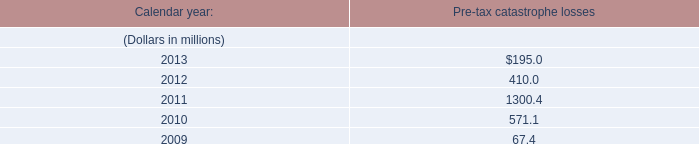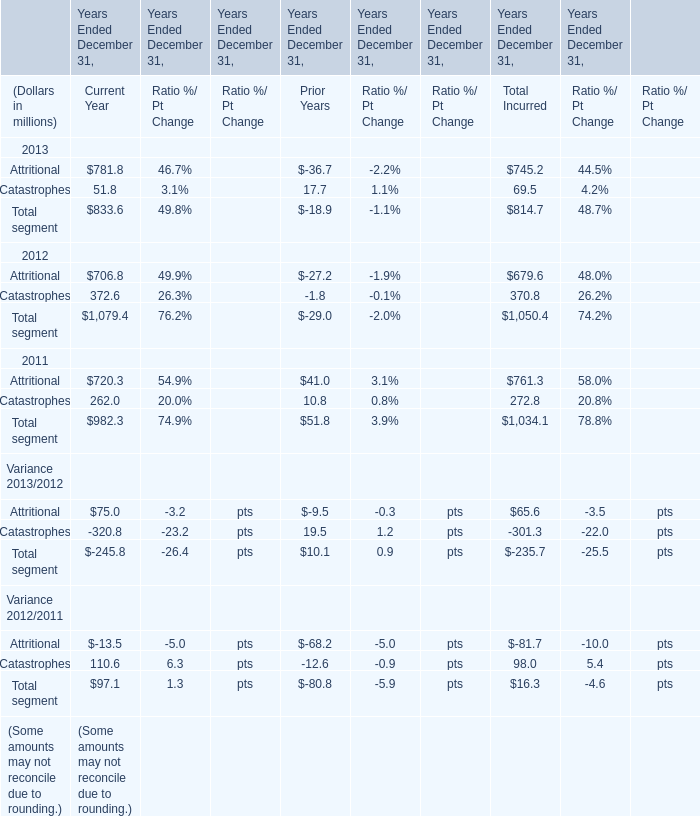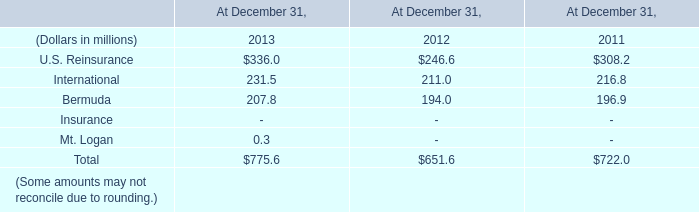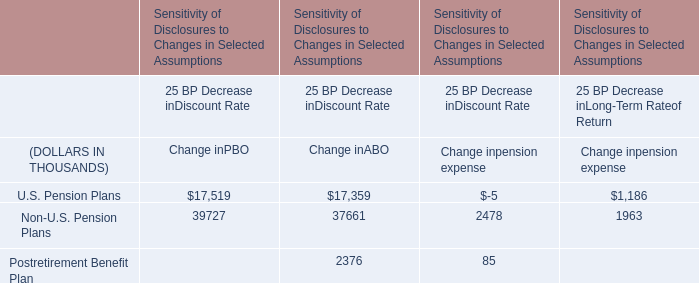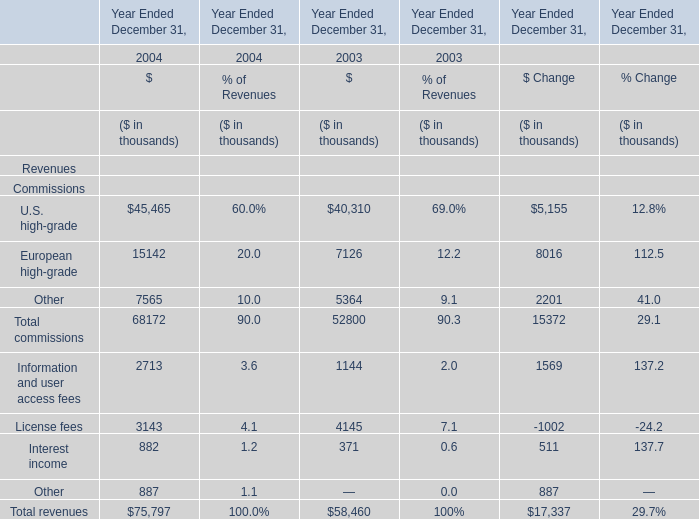What was the average value of the Total segment for Total Incurred in the years where Attritional for Total Incurred is positive? (in million) 
Computations: (((814.7 + 1050.4) + 1034.1) / 3)
Answer: 966.4. 